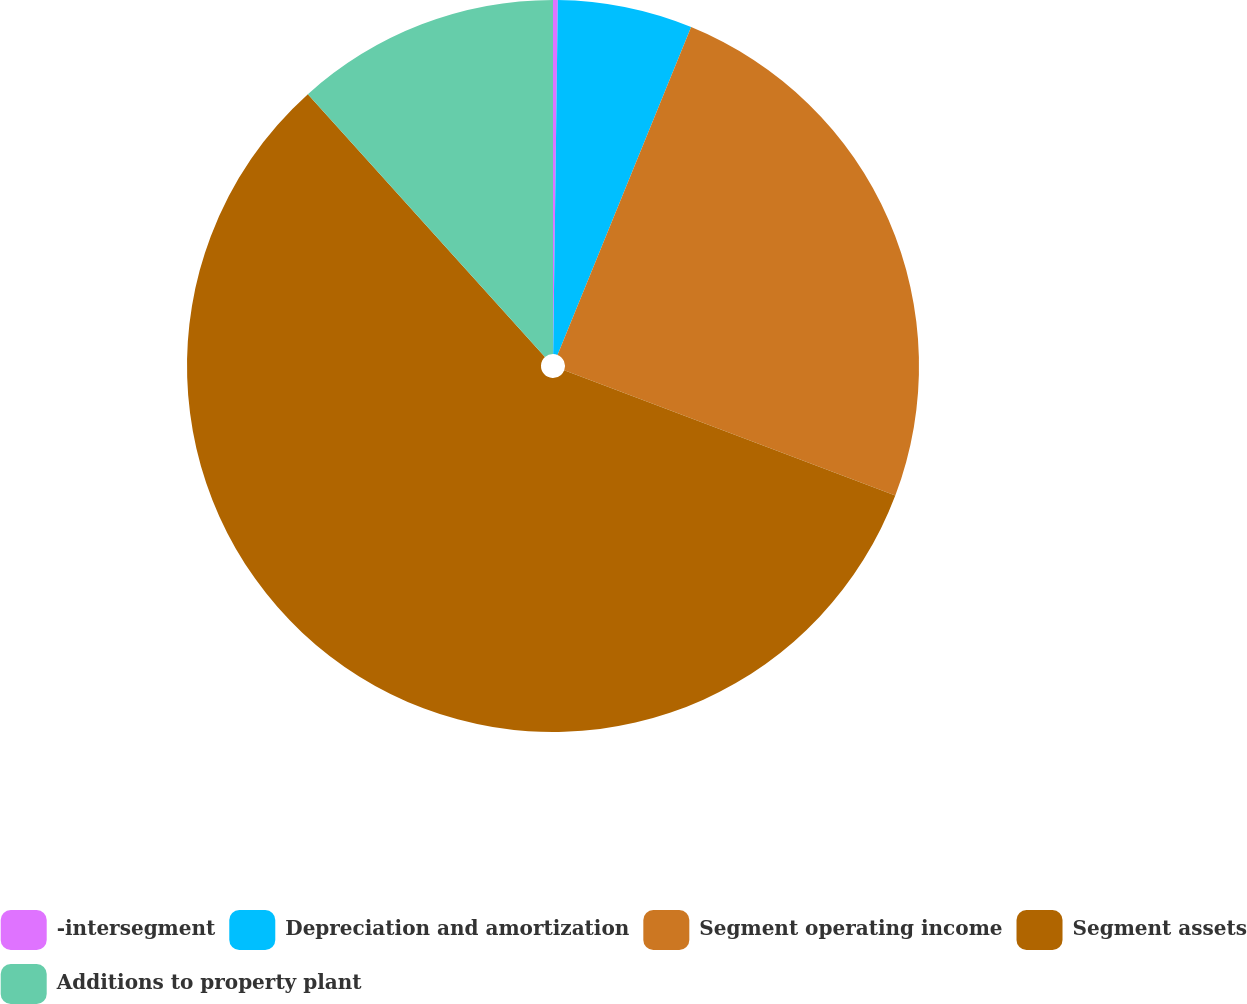Convert chart. <chart><loc_0><loc_0><loc_500><loc_500><pie_chart><fcel>-intersegment<fcel>Depreciation and amortization<fcel>Segment operating income<fcel>Segment assets<fcel>Additions to property plant<nl><fcel>0.21%<fcel>5.95%<fcel>24.6%<fcel>57.56%<fcel>11.68%<nl></chart> 